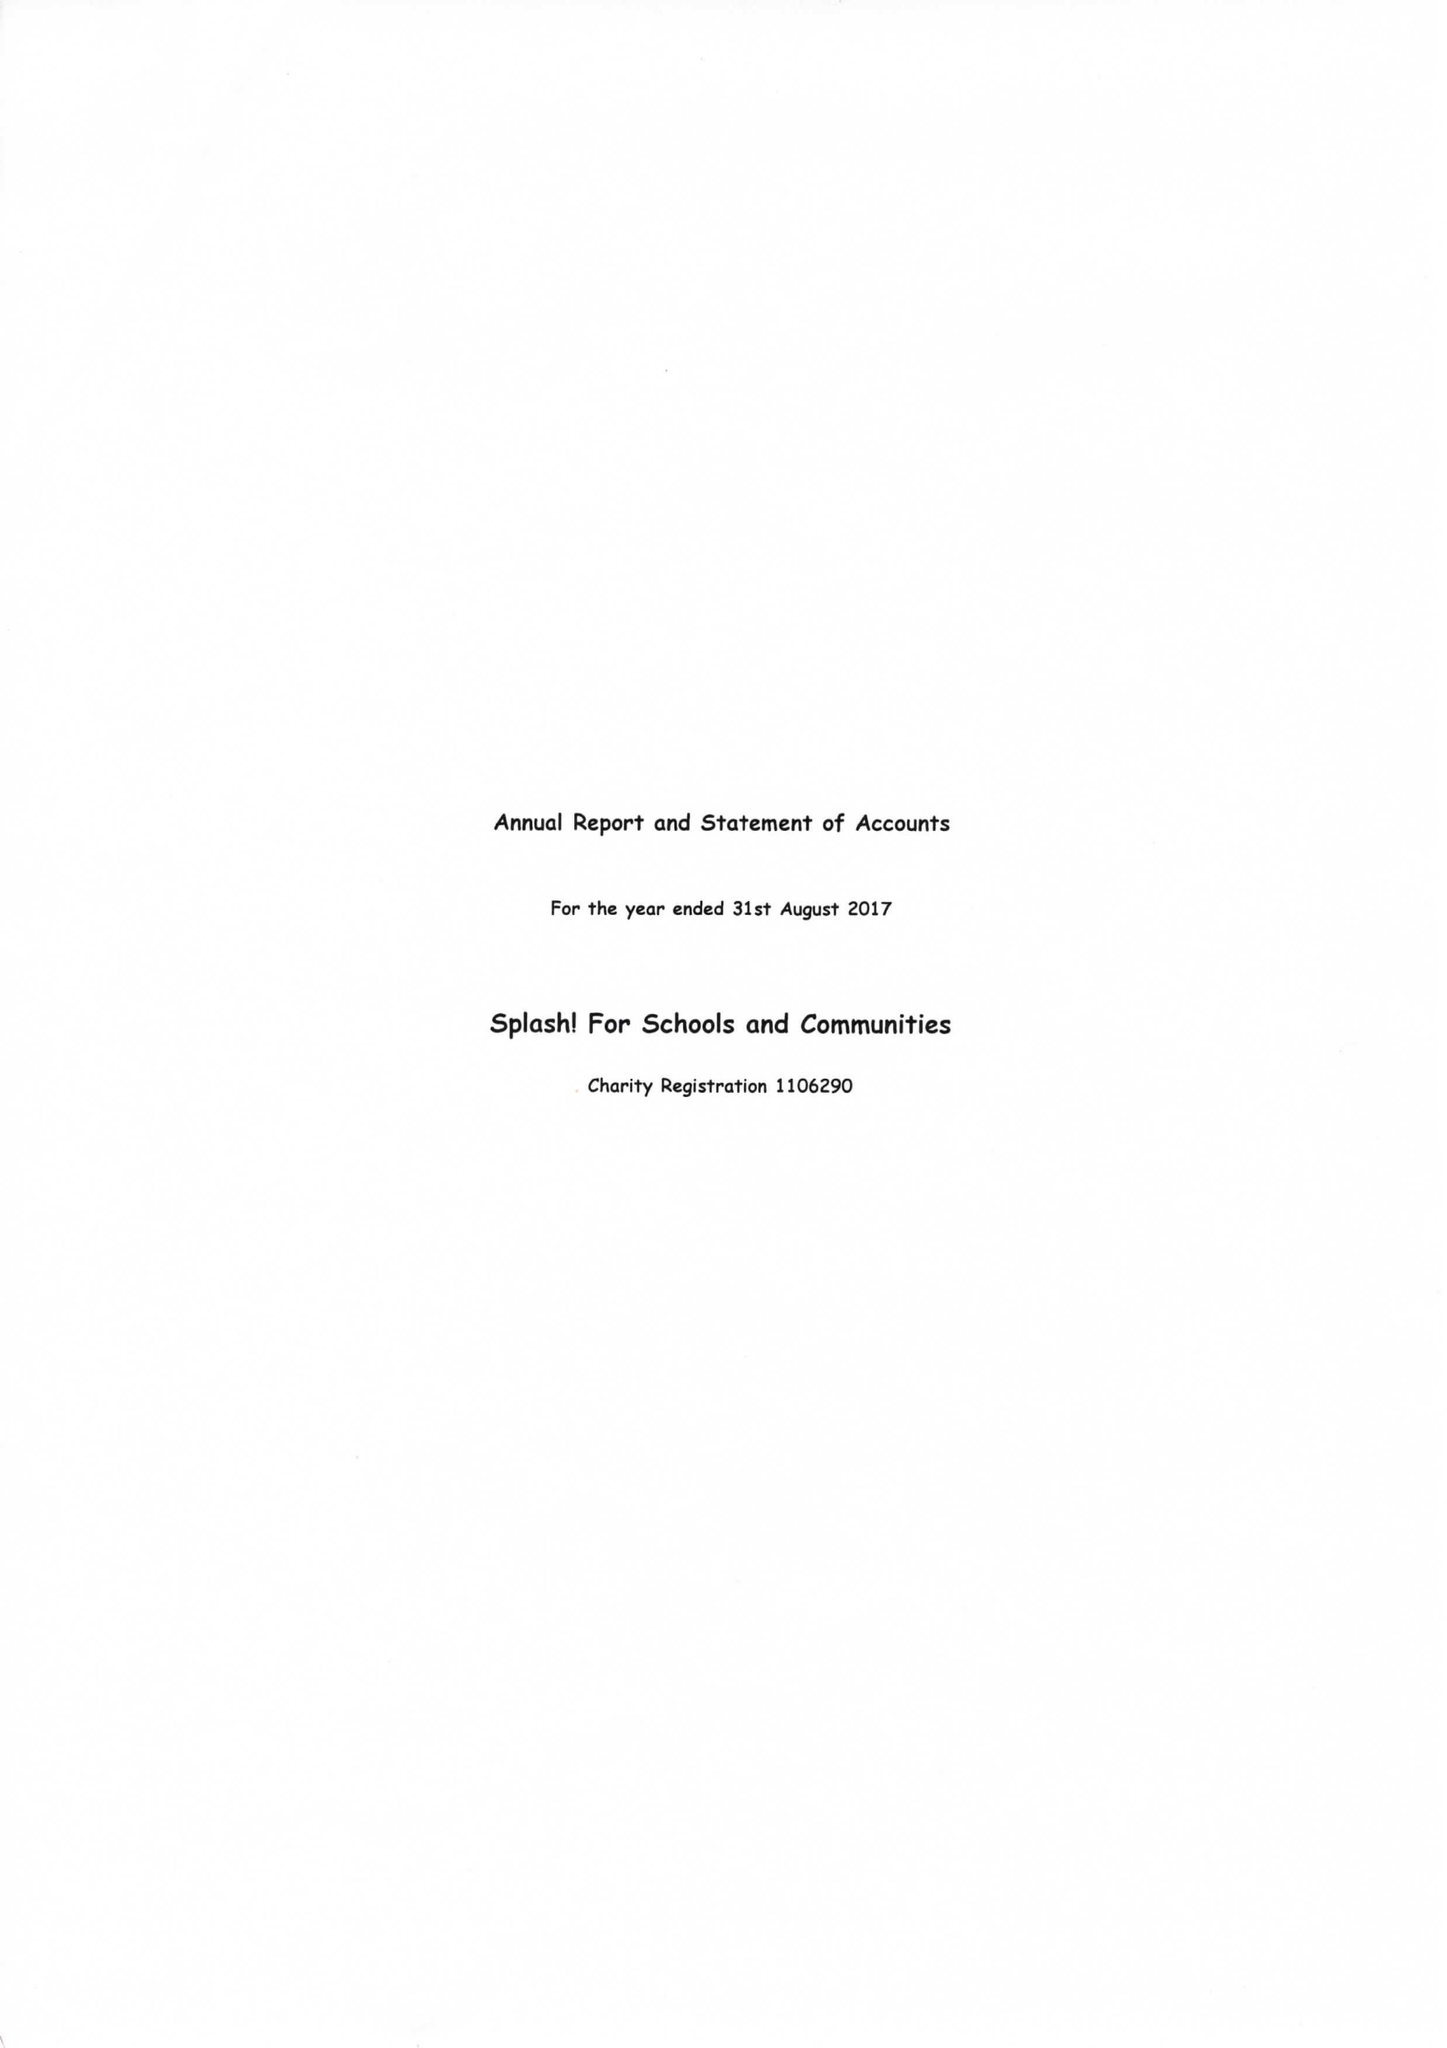What is the value for the address__postcode?
Answer the question using a single word or phrase. RH20 3JX 